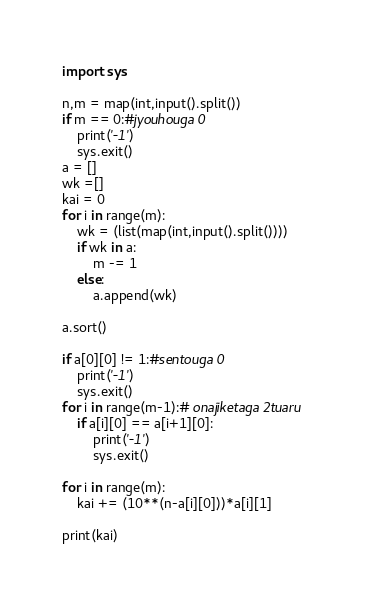Convert code to text. <code><loc_0><loc_0><loc_500><loc_500><_Python_>import sys

n,m = map(int,input().split())
if m == 0:#jyouhouga 0
    print('-1')
    sys.exit()
a = []
wk =[]
kai = 0
for i in range(m):
    wk = (list(map(int,input().split())))
    if wk in a:
        m -= 1
    else:
        a.append(wk)

a.sort()

if a[0][0] != 1:#sentouga 0
    print('-1')
    sys.exit()
for i in range(m-1):# onajiketaga 2tuaru
    if a[i][0] == a[i+1][0]:
        print('-1')
        sys.exit()

for i in range(m):
    kai += (10**(n-a[i][0]))*a[i][1]

print(kai)</code> 